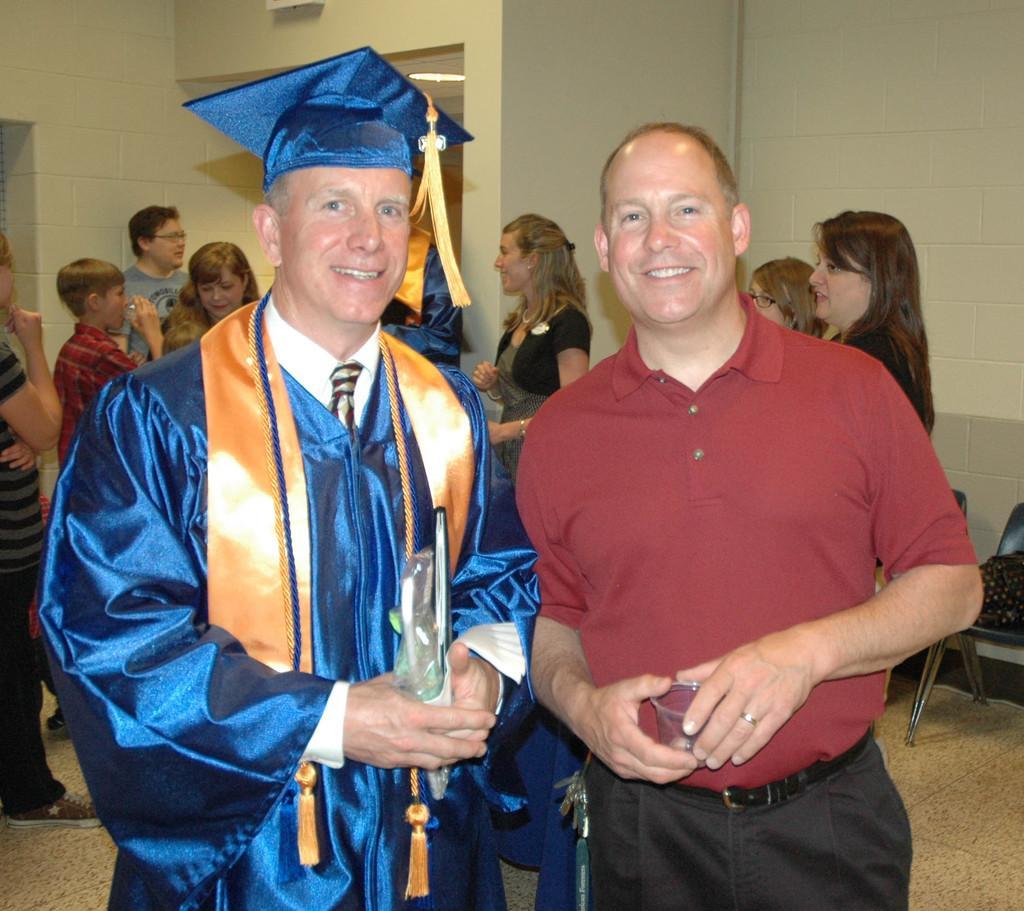Could you give a brief overview of what you see in this image? In this image we can see two men are standing and holding books and glass in their hands. In the background we can see few persons, light on the ceiling, wall, objects and chairs on the floor. 